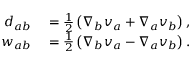Convert formula to latex. <formula><loc_0><loc_0><loc_500><loc_500>\begin{array} { r l } { { d } _ { a b } } & = \frac { 1 } { 2 } \left ( \nabla _ { b } { v } _ { a } + \nabla _ { a } { v } _ { b } \right ) , } \\ { { w } _ { a b } } & = \frac { 1 } { 2 } \left ( \nabla _ { b } { v } _ { a } - \nabla _ { a } { v } _ { b } \right ) . } \end{array}</formula> 